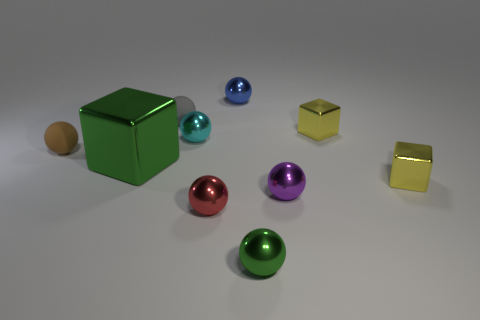Subtract all brown cylinders. How many yellow blocks are left? 2 Subtract all large green metallic cubes. How many cubes are left? 2 Subtract all gray spheres. How many spheres are left? 6 Subtract 5 spheres. How many spheres are left? 2 Subtract all blocks. How many objects are left? 7 Subtract all brown spheres. Subtract all cyan blocks. How many spheres are left? 6 Subtract all yellow rubber balls. Subtract all cyan shiny objects. How many objects are left? 9 Add 5 small brown rubber things. How many small brown rubber things are left? 6 Add 4 blue balls. How many blue balls exist? 5 Subtract 1 brown balls. How many objects are left? 9 